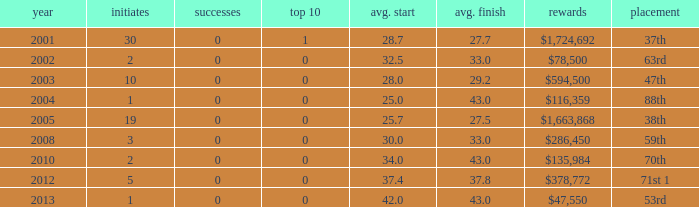What is the average top 10 score for 2 starts, winnings of $135,984 and an average finish more than 43? None. 